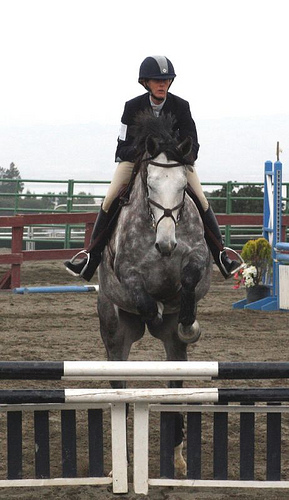<image>
Can you confirm if the helmet is in the horse? No. The helmet is not contained within the horse. These objects have a different spatial relationship. 